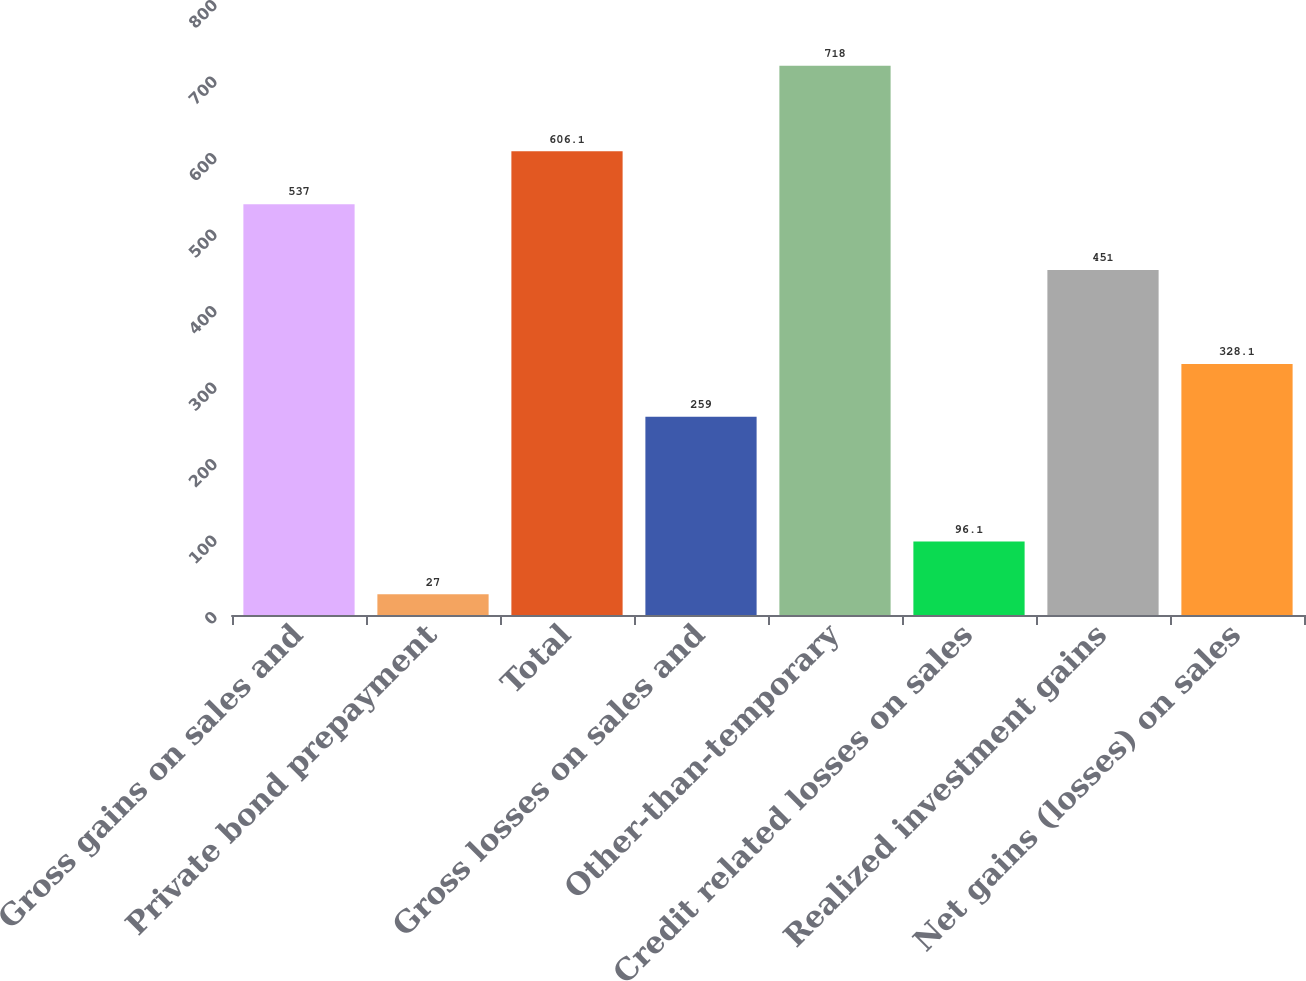Convert chart. <chart><loc_0><loc_0><loc_500><loc_500><bar_chart><fcel>Gross gains on sales and<fcel>Private bond prepayment<fcel>Total<fcel>Gross losses on sales and<fcel>Other-than-temporary<fcel>Credit related losses on sales<fcel>Realized investment gains<fcel>Net gains (losses) on sales<nl><fcel>537<fcel>27<fcel>606.1<fcel>259<fcel>718<fcel>96.1<fcel>451<fcel>328.1<nl></chart> 